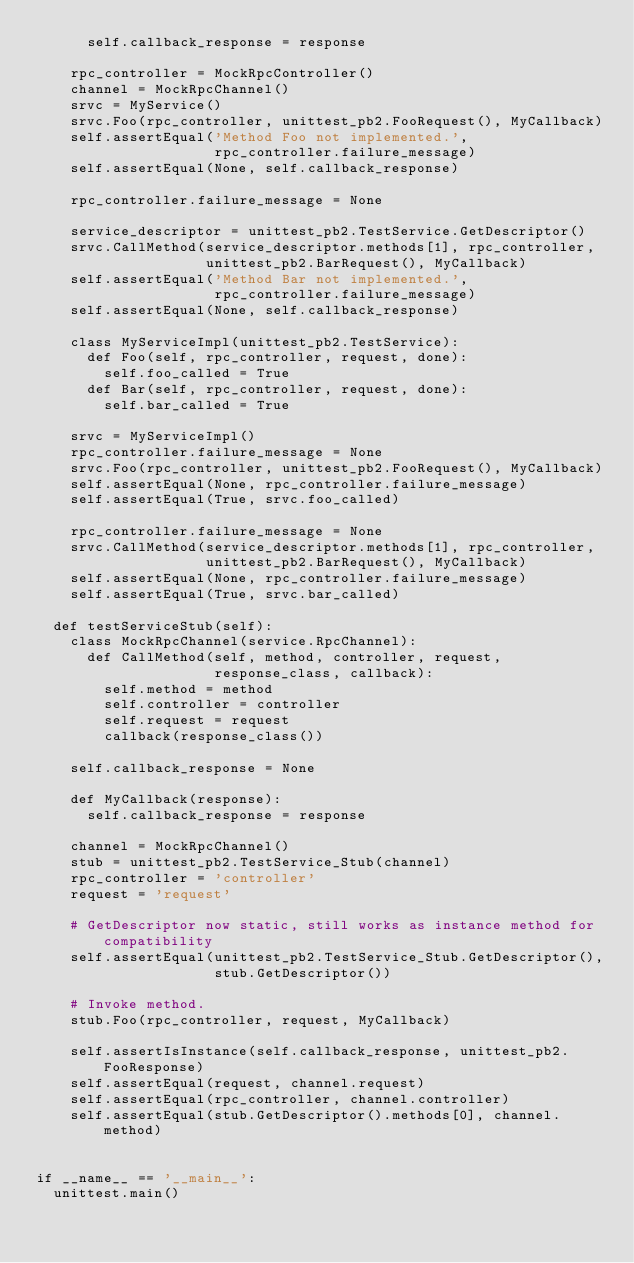Convert code to text. <code><loc_0><loc_0><loc_500><loc_500><_Python_>      self.callback_response = response

    rpc_controller = MockRpcController()
    channel = MockRpcChannel()
    srvc = MyService()
    srvc.Foo(rpc_controller, unittest_pb2.FooRequest(), MyCallback)
    self.assertEqual('Method Foo not implemented.',
                     rpc_controller.failure_message)
    self.assertEqual(None, self.callback_response)

    rpc_controller.failure_message = None

    service_descriptor = unittest_pb2.TestService.GetDescriptor()
    srvc.CallMethod(service_descriptor.methods[1], rpc_controller,
                    unittest_pb2.BarRequest(), MyCallback)
    self.assertEqual('Method Bar not implemented.',
                     rpc_controller.failure_message)
    self.assertEqual(None, self.callback_response)

    class MyServiceImpl(unittest_pb2.TestService):
      def Foo(self, rpc_controller, request, done):
        self.foo_called = True
      def Bar(self, rpc_controller, request, done):
        self.bar_called = True

    srvc = MyServiceImpl()
    rpc_controller.failure_message = None
    srvc.Foo(rpc_controller, unittest_pb2.FooRequest(), MyCallback)
    self.assertEqual(None, rpc_controller.failure_message)
    self.assertEqual(True, srvc.foo_called)

    rpc_controller.failure_message = None
    srvc.CallMethod(service_descriptor.methods[1], rpc_controller,
                    unittest_pb2.BarRequest(), MyCallback)
    self.assertEqual(None, rpc_controller.failure_message)
    self.assertEqual(True, srvc.bar_called)

  def testServiceStub(self):
    class MockRpcChannel(service.RpcChannel):
      def CallMethod(self, method, controller, request,
                     response_class, callback):
        self.method = method
        self.controller = controller
        self.request = request
        callback(response_class())

    self.callback_response = None

    def MyCallback(response):
      self.callback_response = response

    channel = MockRpcChannel()
    stub = unittest_pb2.TestService_Stub(channel)
    rpc_controller = 'controller'
    request = 'request'

    # GetDescriptor now static, still works as instance method for compatibility
    self.assertEqual(unittest_pb2.TestService_Stub.GetDescriptor(),
                     stub.GetDescriptor())

    # Invoke method.
    stub.Foo(rpc_controller, request, MyCallback)

    self.assertIsInstance(self.callback_response, unittest_pb2.FooResponse)
    self.assertEqual(request, channel.request)
    self.assertEqual(rpc_controller, channel.controller)
    self.assertEqual(stub.GetDescriptor().methods[0], channel.method)


if __name__ == '__main__':
  unittest.main()
</code> 